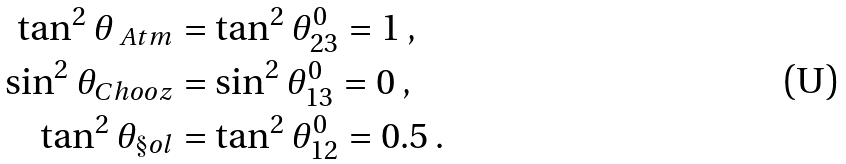<formula> <loc_0><loc_0><loc_500><loc_500>\tan ^ { 2 } \theta _ { \ A t m } & = \tan ^ { 2 } \theta _ { 2 3 } ^ { 0 } = 1 \, , \\ \sin ^ { 2 } \theta _ { C h o o z } & = \sin ^ { 2 } \theta _ { 1 3 } ^ { 0 } = 0 \, , \\ \tan ^ { 2 } \theta _ { \S o l } & = \tan ^ { 2 } \theta _ { 1 2 } ^ { 0 } = 0 . 5 \, .</formula> 